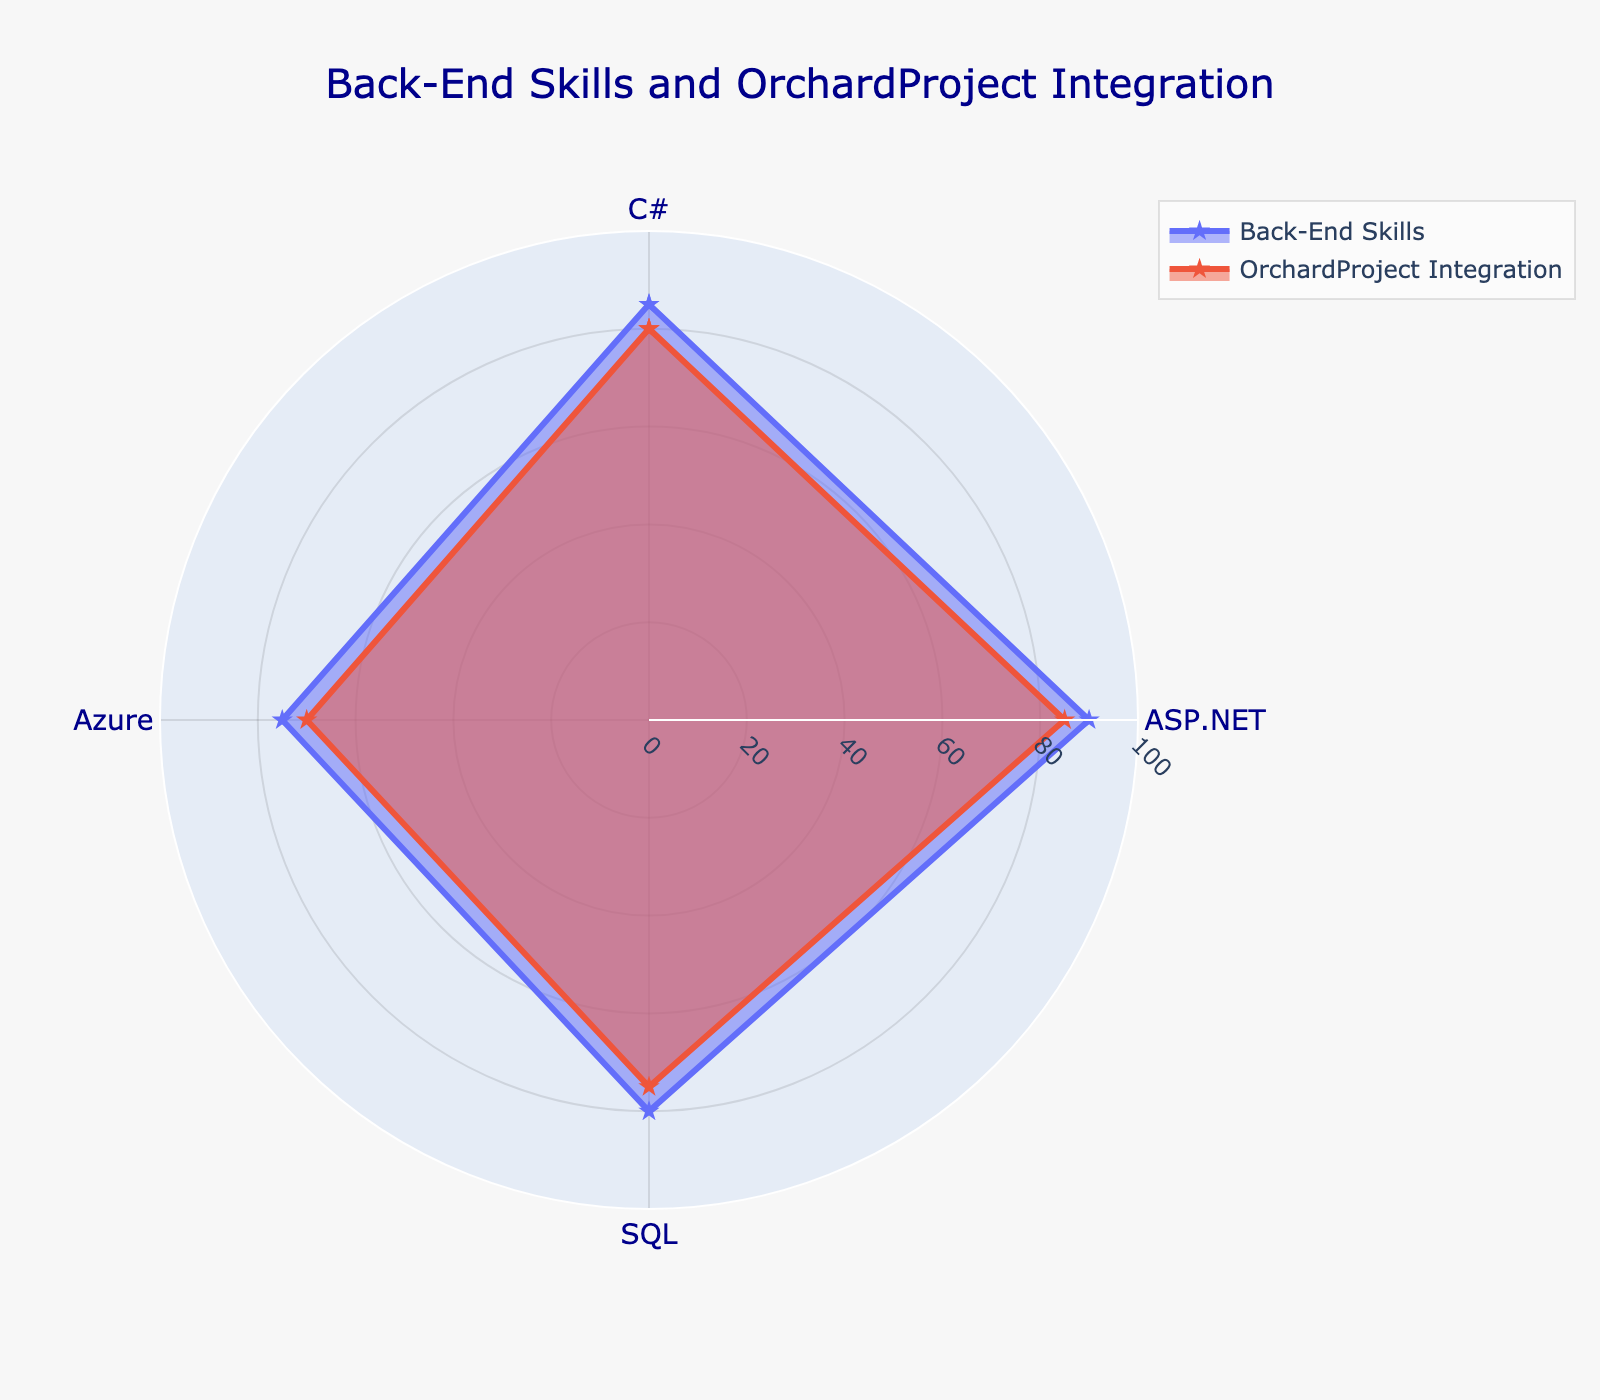What is the title of the radar chart? The title of the radar chart is positioned at the top and is generally a descriptive phrase summarizing the data being presented. In this case, the title combines information about the skills being assessed and the context of the OrchardProject.
Answer: "Back-End Skills and OrchardProject Integration" What is the proficiency in ASP.NET for Back-End Skills? The proficiency in ASP.NET for Back-End Skills is shown as a data point on the radar chart. By looking at the figure, you can find the value associated with ASP.NET in the Back-End Skills category.
Answer: 90 Which category has higher proficiency in C#, Back-End Skills or OrchardProject Integration? To determine which category has higher proficiency in C# between Back-End Skills and OrchardProject Integration, find the values for C# in both categories and compare them. Back-End Skills has a proficiency of 85, while OrchardProject Integration has a proficiency of 80.
Answer: Back-End Skills What is the range of the radial axis? The range of the radial axis is indicated on the radar chart, often showing the minimum and maximum values that the plot can represent. In this case, it ranges from 0 to 100.
Answer: 0 to 100 Which skill has the lowest proficiency in the OrchardProject Integration category? To identify the skill with the lowest proficiency in the OrchardProject Integration category, look at the values for each skill within this category and find the minimum. The lowest proficiency is in Azure with a value of 70.
Answer: Azure What is the sum of proficiency values for SQL across both categories? Sum the proficiency values for SQL in the Back-End Skills and OrchardProject Integration categories. For Back-End Skills, SQL is 80, and for OrchardProject Integration, it is 75. The sum is 80 + 75 = 155.
Answer: 155 What is the average proficiency of Azure across both categories? To find the average proficiency of Azure across both categories, add the values for Azure in each category and divide by the number of categories. The values are 75 (Back-End Skills) and 70 (OrchardProject Integration), so the calculation is (75 + 70) / 2 = 72.5.
Answer: 72.5 How does the proficiency in SQL compare between Back-End Skills and OrchardProject Integration? To compare the proficiency in SQL between the two categories, look at the values for each. Back-End Skills has a proficiency of 80 in SQL, while OrchardProject Integration has a proficiency of 75. This means Back-End Skills has a higher proficiency in SQL by 5 points.
Answer: Back-End Skills is higher Which category shows a more balanced proficiency across all skills? To determine which category shows a more balanced proficiency across all skills, look at the consistency of the values around the radar chart. A category with values that are more equal or less varied would be considered more balanced. In this case, OrchardProject Integration shows more balance as the proficiencies are closer together compared to Back-End Skills.
Answer: OrchardProject Integration What is the proficiency difference in ASP.NET between the two categories? Calculate the proficiency difference in ASP.NET between Back-End Skills (90) and OrchardProject Integration (85) by subtracting the smaller value from the larger one. The difference is 90 - 85 = 5.
Answer: 5 